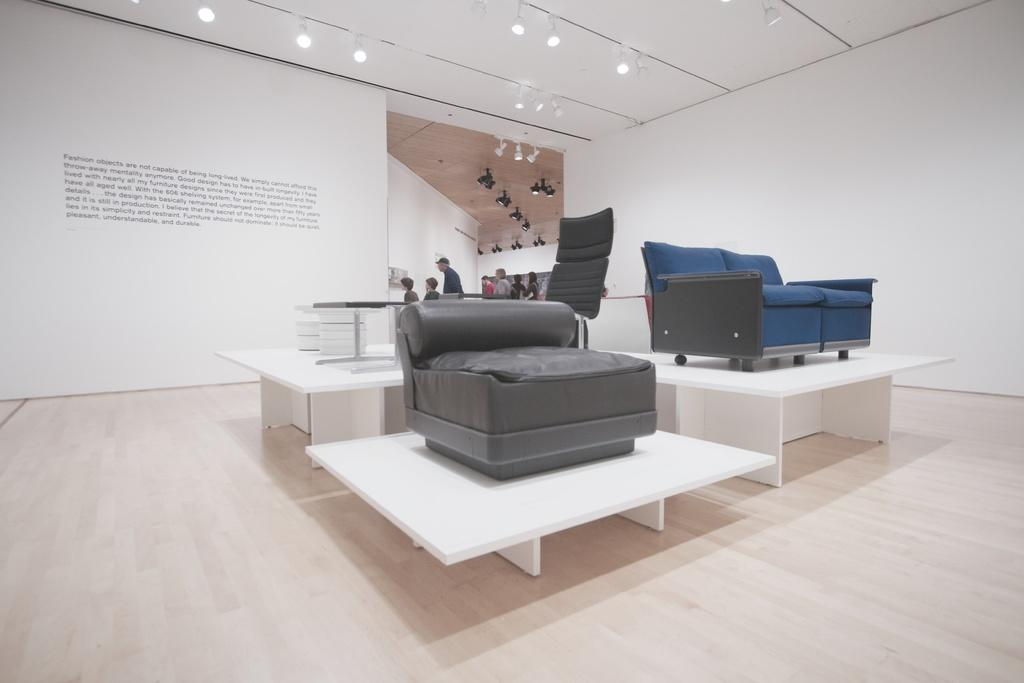How many sofas are visible in the image? There are two sofas in the image. What is the sofas resting on? The sofas are on a wooden table. Where is the wooden table located? The wooden table is on the floor. Can you describe the people in the background of the image? There is a group of people in the background of the image. What type of metal is used to make the seats of the sofas in the image? The sofas in the image do not have metal seats; they are likely made of fabric or another material. How many tickets are visible in the image? There are no tickets present in the image. 